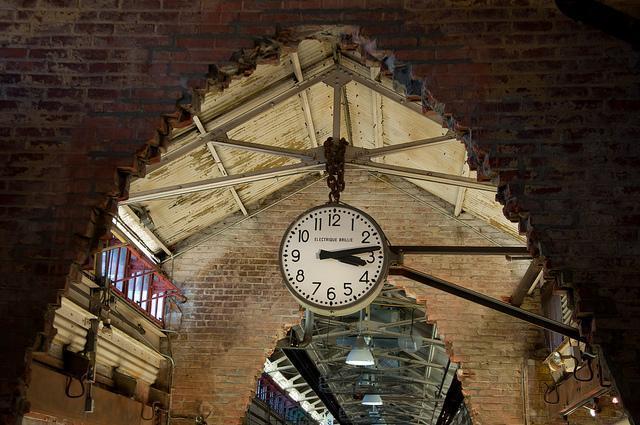How many people are there?
Give a very brief answer. 0. How many people appear in the painting above the clock?
Give a very brief answer. 0. 